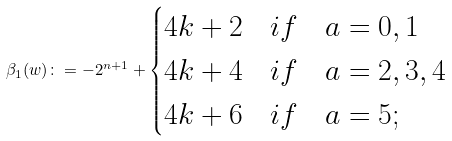Convert formula to latex. <formula><loc_0><loc_0><loc_500><loc_500>\beta _ { 1 } ( w ) \colon = - 2 ^ { n + 1 } + \begin{cases} 4 k + 2 & i f \quad a = 0 , 1 \\ 4 k + 4 & i f \quad a = 2 , 3 , 4 \\ 4 k + 6 & i f \quad a = 5 ; \end{cases}</formula> 